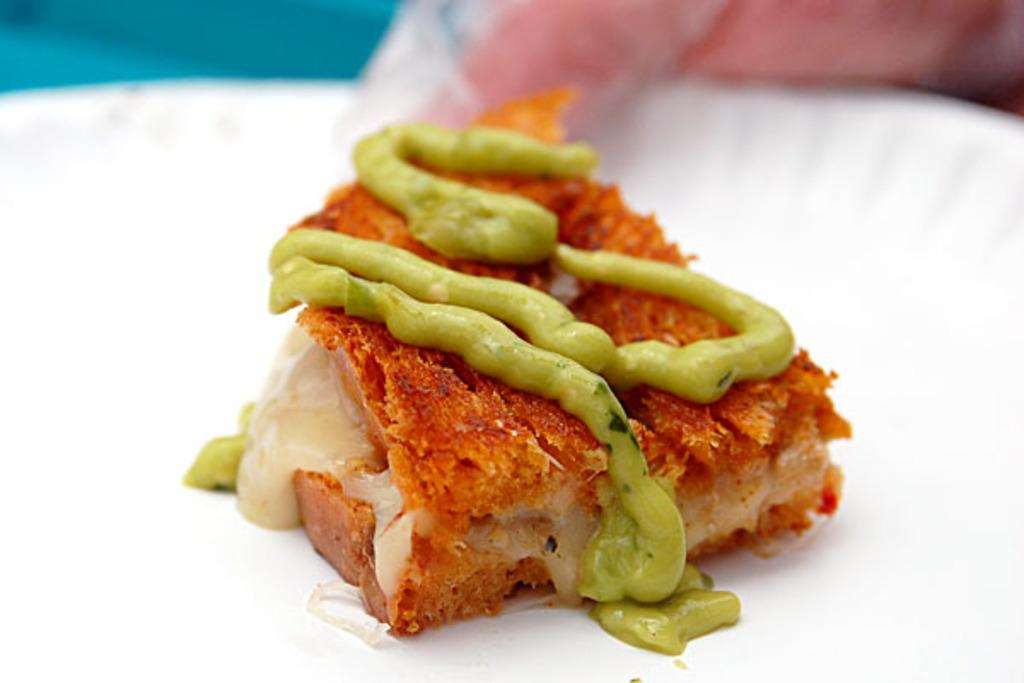What is the main object in the center of the image? There is a white color plate in the center of the image. What is on the plate? The plate contains some food item. Can you describe the background of the image? There is a pink color object in the background of the image. How many lizards can be seen crawling on the plate in the image? There are no lizards present in the image; the plate contains a food item. What type of glass is used to serve the food on the plate? The image does not show any glass being used to serve the food; it only shows a plate with a food item. 